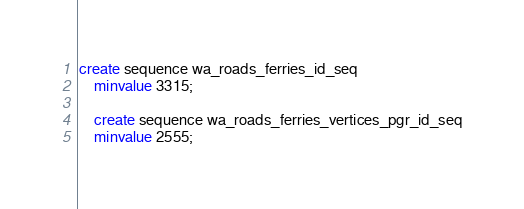<code> <loc_0><loc_0><loc_500><loc_500><_SQL_>create sequence wa_roads_ferries_id_seq
    minvalue 3315;

    create sequence wa_roads_ferries_vertices_pgr_id_seq
    minvalue 2555;</code> 